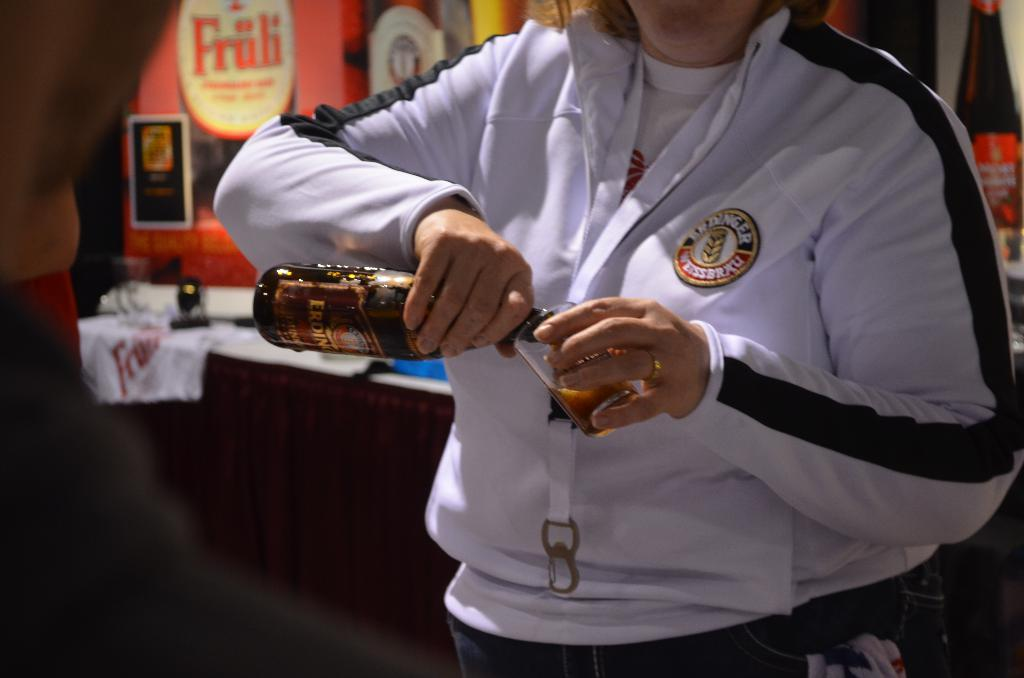Who is present in the image? There is a person in the image. What is the person holding in the image? The person is holding a bottle. What action is the person performing with the bottle? The person is pouring liquid from the bottle. What is the purpose of the glass in the image? The glass is likely intended to hold the liquid being poured from the bottle. What type of plastic is the person using to pour the liquid in the image? There is no plastic mentioned or visible in the image; the person is holding a bottle and pouring liquid from it. 